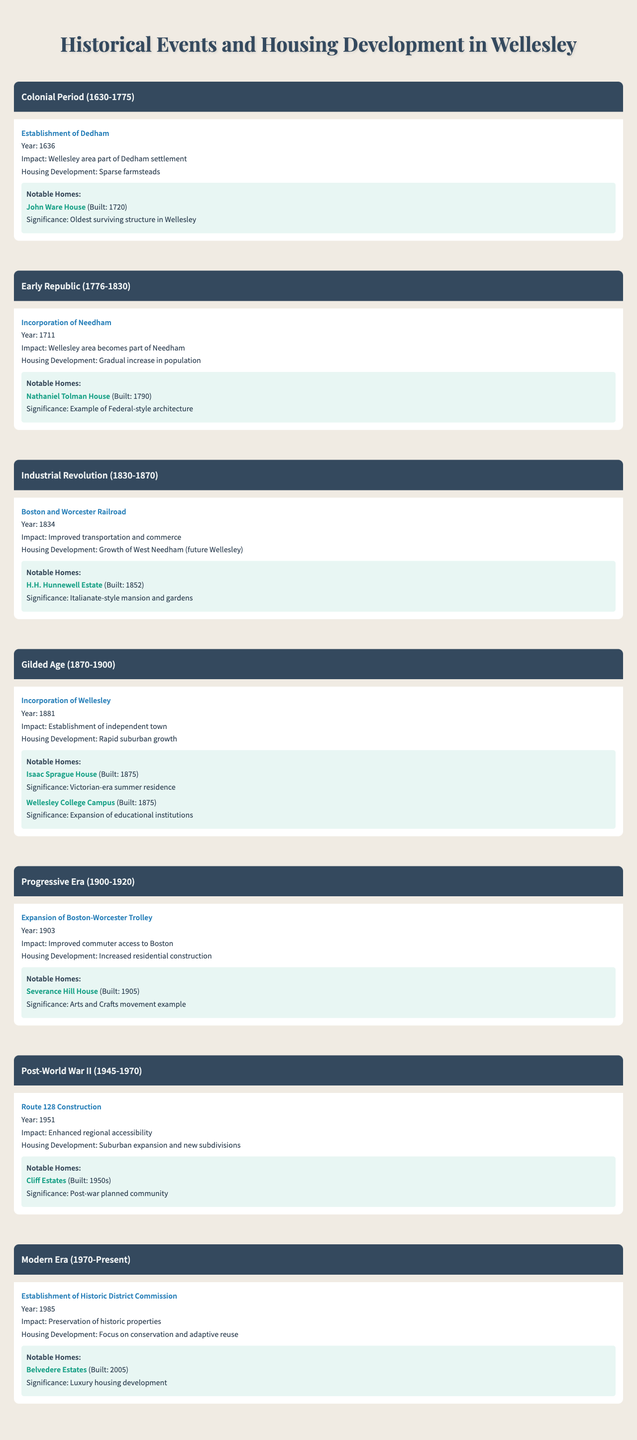What notable home was built in 1720? According to the table, the notable home built in 1720 is the John Ware House.
Answer: John Ware House Which event led to a gradual increase in population in Wellesley? The table indicates that the incorporation of Needham in 1711 caused a gradual increase in population in the Wellesley area.
Answer: Incorporation of Needham What was the significance of the H.H. Hunnewell Estate? The table specifies that the H.H. Hunnewell Estate, built in 1852, is significant as an Italianate-style mansion and gardens.
Answer: Italianate-style mansion In which era did the Boston and Worcester Railroad improve transportation? Based on the table, the era in which the Boston and Worcester Railroad improved transportation is the Industrial Revolution (1830-1870).
Answer: Industrial Revolution How many notable homes were built during the Gilded Age? The table lists two notable homes built during the Gilded Age: the Isaac Sprague House and the Wellesley College Campus. Therefore, the total is two.
Answer: 2 Was the establishment of Wellesley an event in the Gilded Age? The table states that the incorporation of Wellesley occurred in 1881, which is part of the Gilded Age, confirming that it is true.
Answer: Yes Which era saw the expansion of the Boston-Worcester Trolley, and what was its impact? The table shows that the Boston-Worcester Trolley expanded during the Progressive Era (1900-1920), leading to improved commuter access to Boston.
Answer: Progressive Era, improved commuter access What housing development trend occurred after Route 128 Construction in 1951? The data indicates that after Route 128 Construction in 1951, there was suburban expansion and new subdivisions in Wellesley.
Answer: Suburban expansion and new subdivisions List all notable homes built between the Colonial Period and the Industrial Revolution. The table includes the John Ware House (1720), Nathaniel Tolman House (1790), and H.H. Hunnewell Estate (1852) built within these periods.
Answer: John Ware House, Nathaniel Tolman House, H.H. Hunnewell Estate How has Wellesley responded to the need for preservation of historic properties? According to the table, Wellesley established the Historic District Commission in 1985 for the preservation of historic properties, indicating a focused response on conservation.
Answer: Established Historic District Commission in 1985 